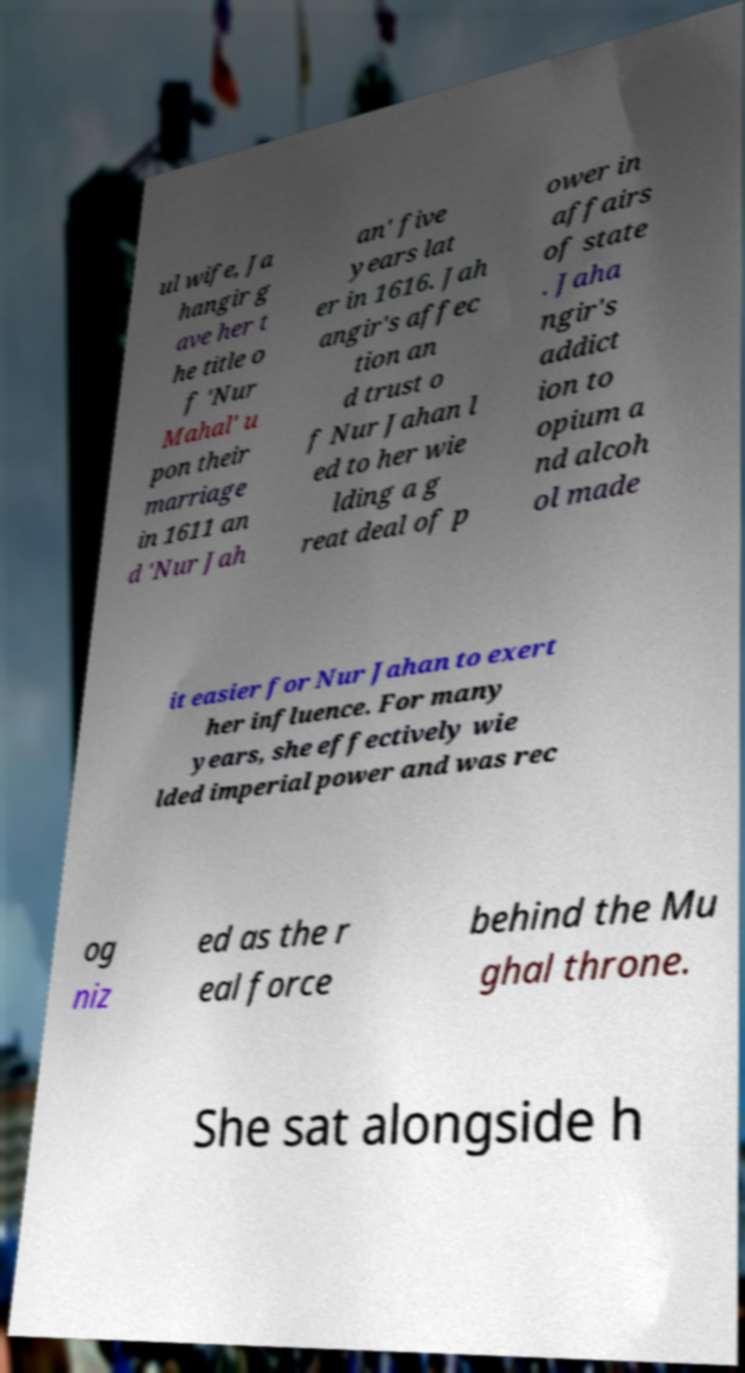Could you assist in decoding the text presented in this image and type it out clearly? ul wife, Ja hangir g ave her t he title o f 'Nur Mahal' u pon their marriage in 1611 an d 'Nur Jah an' five years lat er in 1616. Jah angir's affec tion an d trust o f Nur Jahan l ed to her wie lding a g reat deal of p ower in affairs of state . Jaha ngir's addict ion to opium a nd alcoh ol made it easier for Nur Jahan to exert her influence. For many years, she effectively wie lded imperial power and was rec og niz ed as the r eal force behind the Mu ghal throne. She sat alongside h 